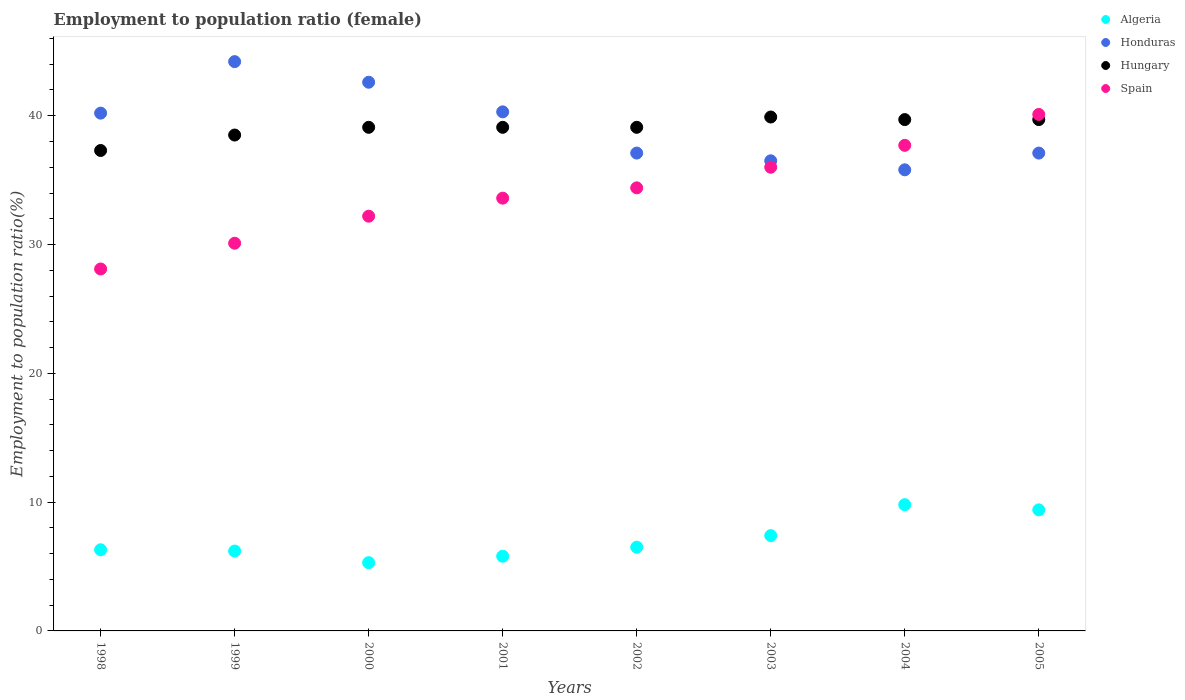How many different coloured dotlines are there?
Make the answer very short. 4. What is the employment to population ratio in Honduras in 2000?
Your response must be concise. 42.6. Across all years, what is the maximum employment to population ratio in Spain?
Offer a terse response. 40.1. Across all years, what is the minimum employment to population ratio in Spain?
Make the answer very short. 28.1. In which year was the employment to population ratio in Algeria minimum?
Your answer should be compact. 2000. What is the total employment to population ratio in Hungary in the graph?
Ensure brevity in your answer.  312.4. What is the difference between the employment to population ratio in Algeria in 2000 and that in 2002?
Your answer should be compact. -1.2. What is the difference between the employment to population ratio in Spain in 1998 and the employment to population ratio in Honduras in 1999?
Give a very brief answer. -16.1. What is the average employment to population ratio in Hungary per year?
Give a very brief answer. 39.05. In the year 2003, what is the difference between the employment to population ratio in Hungary and employment to population ratio in Spain?
Your response must be concise. 3.9. In how many years, is the employment to population ratio in Honduras greater than 14 %?
Keep it short and to the point. 8. What is the ratio of the employment to population ratio in Algeria in 1998 to that in 2003?
Make the answer very short. 0.85. Is the employment to population ratio in Spain in 2001 less than that in 2004?
Your answer should be very brief. Yes. Is the difference between the employment to population ratio in Hungary in 2000 and 2005 greater than the difference between the employment to population ratio in Spain in 2000 and 2005?
Provide a short and direct response. Yes. What is the difference between the highest and the second highest employment to population ratio in Spain?
Keep it short and to the point. 2.4. What is the difference between the highest and the lowest employment to population ratio in Spain?
Your answer should be compact. 12. In how many years, is the employment to population ratio in Algeria greater than the average employment to population ratio in Algeria taken over all years?
Make the answer very short. 3. Is it the case that in every year, the sum of the employment to population ratio in Hungary and employment to population ratio in Spain  is greater than the sum of employment to population ratio in Algeria and employment to population ratio in Honduras?
Keep it short and to the point. No. Is it the case that in every year, the sum of the employment to population ratio in Spain and employment to population ratio in Honduras  is greater than the employment to population ratio in Algeria?
Your answer should be compact. Yes. Is the employment to population ratio in Honduras strictly greater than the employment to population ratio in Algeria over the years?
Your answer should be compact. Yes. Is the employment to population ratio in Honduras strictly less than the employment to population ratio in Hungary over the years?
Your response must be concise. No. Are the values on the major ticks of Y-axis written in scientific E-notation?
Ensure brevity in your answer.  No. Does the graph contain grids?
Your response must be concise. No. Where does the legend appear in the graph?
Keep it short and to the point. Top right. How many legend labels are there?
Offer a terse response. 4. How are the legend labels stacked?
Ensure brevity in your answer.  Vertical. What is the title of the graph?
Provide a succinct answer. Employment to population ratio (female). Does "Austria" appear as one of the legend labels in the graph?
Offer a terse response. No. What is the Employment to population ratio(%) of Algeria in 1998?
Offer a very short reply. 6.3. What is the Employment to population ratio(%) of Honduras in 1998?
Provide a succinct answer. 40.2. What is the Employment to population ratio(%) of Hungary in 1998?
Your answer should be compact. 37.3. What is the Employment to population ratio(%) in Spain in 1998?
Give a very brief answer. 28.1. What is the Employment to population ratio(%) of Algeria in 1999?
Provide a succinct answer. 6.2. What is the Employment to population ratio(%) of Honduras in 1999?
Offer a terse response. 44.2. What is the Employment to population ratio(%) in Hungary in 1999?
Your answer should be very brief. 38.5. What is the Employment to population ratio(%) in Spain in 1999?
Provide a short and direct response. 30.1. What is the Employment to population ratio(%) of Algeria in 2000?
Give a very brief answer. 5.3. What is the Employment to population ratio(%) of Honduras in 2000?
Offer a terse response. 42.6. What is the Employment to population ratio(%) of Hungary in 2000?
Your response must be concise. 39.1. What is the Employment to population ratio(%) in Spain in 2000?
Your answer should be compact. 32.2. What is the Employment to population ratio(%) of Algeria in 2001?
Ensure brevity in your answer.  5.8. What is the Employment to population ratio(%) in Honduras in 2001?
Give a very brief answer. 40.3. What is the Employment to population ratio(%) of Hungary in 2001?
Offer a very short reply. 39.1. What is the Employment to population ratio(%) in Spain in 2001?
Your answer should be very brief. 33.6. What is the Employment to population ratio(%) in Honduras in 2002?
Offer a very short reply. 37.1. What is the Employment to population ratio(%) in Hungary in 2002?
Your answer should be compact. 39.1. What is the Employment to population ratio(%) in Spain in 2002?
Ensure brevity in your answer.  34.4. What is the Employment to population ratio(%) of Algeria in 2003?
Your response must be concise. 7.4. What is the Employment to population ratio(%) in Honduras in 2003?
Provide a succinct answer. 36.5. What is the Employment to population ratio(%) in Hungary in 2003?
Make the answer very short. 39.9. What is the Employment to population ratio(%) of Spain in 2003?
Offer a terse response. 36. What is the Employment to population ratio(%) of Algeria in 2004?
Your answer should be compact. 9.8. What is the Employment to population ratio(%) of Honduras in 2004?
Ensure brevity in your answer.  35.8. What is the Employment to population ratio(%) of Hungary in 2004?
Provide a succinct answer. 39.7. What is the Employment to population ratio(%) in Spain in 2004?
Make the answer very short. 37.7. What is the Employment to population ratio(%) of Algeria in 2005?
Offer a very short reply. 9.4. What is the Employment to population ratio(%) in Honduras in 2005?
Offer a terse response. 37.1. What is the Employment to population ratio(%) of Hungary in 2005?
Your answer should be compact. 39.7. What is the Employment to population ratio(%) in Spain in 2005?
Ensure brevity in your answer.  40.1. Across all years, what is the maximum Employment to population ratio(%) in Algeria?
Your answer should be compact. 9.8. Across all years, what is the maximum Employment to population ratio(%) of Honduras?
Provide a succinct answer. 44.2. Across all years, what is the maximum Employment to population ratio(%) of Hungary?
Provide a short and direct response. 39.9. Across all years, what is the maximum Employment to population ratio(%) of Spain?
Offer a terse response. 40.1. Across all years, what is the minimum Employment to population ratio(%) of Algeria?
Offer a terse response. 5.3. Across all years, what is the minimum Employment to population ratio(%) of Honduras?
Your response must be concise. 35.8. Across all years, what is the minimum Employment to population ratio(%) of Hungary?
Provide a succinct answer. 37.3. Across all years, what is the minimum Employment to population ratio(%) in Spain?
Ensure brevity in your answer.  28.1. What is the total Employment to population ratio(%) of Algeria in the graph?
Keep it short and to the point. 56.7. What is the total Employment to population ratio(%) of Honduras in the graph?
Give a very brief answer. 313.8. What is the total Employment to population ratio(%) of Hungary in the graph?
Provide a succinct answer. 312.4. What is the total Employment to population ratio(%) of Spain in the graph?
Provide a short and direct response. 272.2. What is the difference between the Employment to population ratio(%) of Algeria in 1998 and that in 1999?
Your answer should be compact. 0.1. What is the difference between the Employment to population ratio(%) in Hungary in 1998 and that in 1999?
Keep it short and to the point. -1.2. What is the difference between the Employment to population ratio(%) of Spain in 1998 and that in 1999?
Your answer should be very brief. -2. What is the difference between the Employment to population ratio(%) in Honduras in 1998 and that in 2000?
Give a very brief answer. -2.4. What is the difference between the Employment to population ratio(%) in Hungary in 1998 and that in 2000?
Offer a very short reply. -1.8. What is the difference between the Employment to population ratio(%) in Honduras in 1998 and that in 2001?
Your answer should be compact. -0.1. What is the difference between the Employment to population ratio(%) in Algeria in 1998 and that in 2002?
Make the answer very short. -0.2. What is the difference between the Employment to population ratio(%) of Honduras in 1998 and that in 2002?
Ensure brevity in your answer.  3.1. What is the difference between the Employment to population ratio(%) in Hungary in 1998 and that in 2002?
Your answer should be compact. -1.8. What is the difference between the Employment to population ratio(%) of Spain in 1998 and that in 2002?
Ensure brevity in your answer.  -6.3. What is the difference between the Employment to population ratio(%) in Algeria in 1998 and that in 2003?
Offer a very short reply. -1.1. What is the difference between the Employment to population ratio(%) of Hungary in 1998 and that in 2003?
Your response must be concise. -2.6. What is the difference between the Employment to population ratio(%) in Algeria in 1998 and that in 2004?
Your response must be concise. -3.5. What is the difference between the Employment to population ratio(%) in Honduras in 1998 and that in 2004?
Your answer should be compact. 4.4. What is the difference between the Employment to population ratio(%) of Spain in 1998 and that in 2004?
Your response must be concise. -9.6. What is the difference between the Employment to population ratio(%) in Hungary in 1998 and that in 2005?
Your answer should be very brief. -2.4. What is the difference between the Employment to population ratio(%) of Algeria in 1999 and that in 2000?
Make the answer very short. 0.9. What is the difference between the Employment to population ratio(%) in Hungary in 1999 and that in 2000?
Give a very brief answer. -0.6. What is the difference between the Employment to population ratio(%) of Spain in 1999 and that in 2001?
Provide a succinct answer. -3.5. What is the difference between the Employment to population ratio(%) in Algeria in 1999 and that in 2002?
Make the answer very short. -0.3. What is the difference between the Employment to population ratio(%) in Honduras in 1999 and that in 2002?
Give a very brief answer. 7.1. What is the difference between the Employment to population ratio(%) of Spain in 1999 and that in 2002?
Make the answer very short. -4.3. What is the difference between the Employment to population ratio(%) of Honduras in 1999 and that in 2003?
Offer a terse response. 7.7. What is the difference between the Employment to population ratio(%) in Hungary in 1999 and that in 2003?
Your response must be concise. -1.4. What is the difference between the Employment to population ratio(%) in Algeria in 1999 and that in 2004?
Your answer should be compact. -3.6. What is the difference between the Employment to population ratio(%) of Spain in 1999 and that in 2004?
Give a very brief answer. -7.6. What is the difference between the Employment to population ratio(%) in Honduras in 1999 and that in 2005?
Ensure brevity in your answer.  7.1. What is the difference between the Employment to population ratio(%) of Spain in 1999 and that in 2005?
Give a very brief answer. -10. What is the difference between the Employment to population ratio(%) of Algeria in 2000 and that in 2001?
Provide a succinct answer. -0.5. What is the difference between the Employment to population ratio(%) in Hungary in 2000 and that in 2001?
Give a very brief answer. 0. What is the difference between the Employment to population ratio(%) in Spain in 2000 and that in 2001?
Ensure brevity in your answer.  -1.4. What is the difference between the Employment to population ratio(%) in Honduras in 2000 and that in 2002?
Your response must be concise. 5.5. What is the difference between the Employment to population ratio(%) in Algeria in 2000 and that in 2003?
Your response must be concise. -2.1. What is the difference between the Employment to population ratio(%) in Algeria in 2000 and that in 2004?
Offer a terse response. -4.5. What is the difference between the Employment to population ratio(%) of Honduras in 2000 and that in 2004?
Your response must be concise. 6.8. What is the difference between the Employment to population ratio(%) in Algeria in 2000 and that in 2005?
Give a very brief answer. -4.1. What is the difference between the Employment to population ratio(%) of Hungary in 2000 and that in 2005?
Provide a short and direct response. -0.6. What is the difference between the Employment to population ratio(%) in Algeria in 2001 and that in 2002?
Your answer should be compact. -0.7. What is the difference between the Employment to population ratio(%) in Honduras in 2001 and that in 2002?
Your response must be concise. 3.2. What is the difference between the Employment to population ratio(%) of Spain in 2001 and that in 2002?
Keep it short and to the point. -0.8. What is the difference between the Employment to population ratio(%) in Honduras in 2001 and that in 2003?
Make the answer very short. 3.8. What is the difference between the Employment to population ratio(%) in Spain in 2001 and that in 2003?
Make the answer very short. -2.4. What is the difference between the Employment to population ratio(%) of Hungary in 2001 and that in 2004?
Provide a succinct answer. -0.6. What is the difference between the Employment to population ratio(%) of Spain in 2001 and that in 2004?
Keep it short and to the point. -4.1. What is the difference between the Employment to population ratio(%) of Algeria in 2001 and that in 2005?
Your response must be concise. -3.6. What is the difference between the Employment to population ratio(%) of Hungary in 2001 and that in 2005?
Your response must be concise. -0.6. What is the difference between the Employment to population ratio(%) of Spain in 2001 and that in 2005?
Make the answer very short. -6.5. What is the difference between the Employment to population ratio(%) of Honduras in 2002 and that in 2003?
Your answer should be compact. 0.6. What is the difference between the Employment to population ratio(%) in Hungary in 2002 and that in 2003?
Provide a short and direct response. -0.8. What is the difference between the Employment to population ratio(%) of Spain in 2002 and that in 2003?
Provide a short and direct response. -1.6. What is the difference between the Employment to population ratio(%) in Hungary in 2002 and that in 2004?
Ensure brevity in your answer.  -0.6. What is the difference between the Employment to population ratio(%) in Spain in 2002 and that in 2004?
Your answer should be compact. -3.3. What is the difference between the Employment to population ratio(%) of Honduras in 2003 and that in 2004?
Provide a short and direct response. 0.7. What is the difference between the Employment to population ratio(%) in Hungary in 2003 and that in 2004?
Keep it short and to the point. 0.2. What is the difference between the Employment to population ratio(%) of Algeria in 2003 and that in 2005?
Offer a terse response. -2. What is the difference between the Employment to population ratio(%) of Hungary in 2003 and that in 2005?
Make the answer very short. 0.2. What is the difference between the Employment to population ratio(%) of Algeria in 2004 and that in 2005?
Offer a terse response. 0.4. What is the difference between the Employment to population ratio(%) of Hungary in 2004 and that in 2005?
Your answer should be compact. 0. What is the difference between the Employment to population ratio(%) of Spain in 2004 and that in 2005?
Your response must be concise. -2.4. What is the difference between the Employment to population ratio(%) of Algeria in 1998 and the Employment to population ratio(%) of Honduras in 1999?
Offer a very short reply. -37.9. What is the difference between the Employment to population ratio(%) in Algeria in 1998 and the Employment to population ratio(%) in Hungary in 1999?
Keep it short and to the point. -32.2. What is the difference between the Employment to population ratio(%) of Algeria in 1998 and the Employment to population ratio(%) of Spain in 1999?
Offer a terse response. -23.8. What is the difference between the Employment to population ratio(%) of Algeria in 1998 and the Employment to population ratio(%) of Honduras in 2000?
Make the answer very short. -36.3. What is the difference between the Employment to population ratio(%) in Algeria in 1998 and the Employment to population ratio(%) in Hungary in 2000?
Provide a short and direct response. -32.8. What is the difference between the Employment to population ratio(%) in Algeria in 1998 and the Employment to population ratio(%) in Spain in 2000?
Offer a very short reply. -25.9. What is the difference between the Employment to population ratio(%) of Honduras in 1998 and the Employment to population ratio(%) of Spain in 2000?
Offer a terse response. 8. What is the difference between the Employment to population ratio(%) of Algeria in 1998 and the Employment to population ratio(%) of Honduras in 2001?
Offer a very short reply. -34. What is the difference between the Employment to population ratio(%) in Algeria in 1998 and the Employment to population ratio(%) in Hungary in 2001?
Ensure brevity in your answer.  -32.8. What is the difference between the Employment to population ratio(%) in Algeria in 1998 and the Employment to population ratio(%) in Spain in 2001?
Keep it short and to the point. -27.3. What is the difference between the Employment to population ratio(%) in Honduras in 1998 and the Employment to population ratio(%) in Hungary in 2001?
Offer a terse response. 1.1. What is the difference between the Employment to population ratio(%) of Honduras in 1998 and the Employment to population ratio(%) of Spain in 2001?
Provide a succinct answer. 6.6. What is the difference between the Employment to population ratio(%) in Hungary in 1998 and the Employment to population ratio(%) in Spain in 2001?
Ensure brevity in your answer.  3.7. What is the difference between the Employment to population ratio(%) of Algeria in 1998 and the Employment to population ratio(%) of Honduras in 2002?
Offer a very short reply. -30.8. What is the difference between the Employment to population ratio(%) in Algeria in 1998 and the Employment to population ratio(%) in Hungary in 2002?
Offer a very short reply. -32.8. What is the difference between the Employment to population ratio(%) of Algeria in 1998 and the Employment to population ratio(%) of Spain in 2002?
Make the answer very short. -28.1. What is the difference between the Employment to population ratio(%) of Hungary in 1998 and the Employment to population ratio(%) of Spain in 2002?
Provide a succinct answer. 2.9. What is the difference between the Employment to population ratio(%) in Algeria in 1998 and the Employment to population ratio(%) in Honduras in 2003?
Your response must be concise. -30.2. What is the difference between the Employment to population ratio(%) of Algeria in 1998 and the Employment to population ratio(%) of Hungary in 2003?
Keep it short and to the point. -33.6. What is the difference between the Employment to population ratio(%) in Algeria in 1998 and the Employment to population ratio(%) in Spain in 2003?
Make the answer very short. -29.7. What is the difference between the Employment to population ratio(%) in Honduras in 1998 and the Employment to population ratio(%) in Spain in 2003?
Offer a terse response. 4.2. What is the difference between the Employment to population ratio(%) in Algeria in 1998 and the Employment to population ratio(%) in Honduras in 2004?
Offer a terse response. -29.5. What is the difference between the Employment to population ratio(%) of Algeria in 1998 and the Employment to population ratio(%) of Hungary in 2004?
Provide a succinct answer. -33.4. What is the difference between the Employment to population ratio(%) of Algeria in 1998 and the Employment to population ratio(%) of Spain in 2004?
Ensure brevity in your answer.  -31.4. What is the difference between the Employment to population ratio(%) in Honduras in 1998 and the Employment to population ratio(%) in Hungary in 2004?
Keep it short and to the point. 0.5. What is the difference between the Employment to population ratio(%) of Algeria in 1998 and the Employment to population ratio(%) of Honduras in 2005?
Provide a succinct answer. -30.8. What is the difference between the Employment to population ratio(%) in Algeria in 1998 and the Employment to population ratio(%) in Hungary in 2005?
Your answer should be compact. -33.4. What is the difference between the Employment to population ratio(%) of Algeria in 1998 and the Employment to population ratio(%) of Spain in 2005?
Your response must be concise. -33.8. What is the difference between the Employment to population ratio(%) of Honduras in 1998 and the Employment to population ratio(%) of Hungary in 2005?
Your answer should be very brief. 0.5. What is the difference between the Employment to population ratio(%) of Hungary in 1998 and the Employment to population ratio(%) of Spain in 2005?
Offer a very short reply. -2.8. What is the difference between the Employment to population ratio(%) in Algeria in 1999 and the Employment to population ratio(%) in Honduras in 2000?
Your answer should be compact. -36.4. What is the difference between the Employment to population ratio(%) in Algeria in 1999 and the Employment to population ratio(%) in Hungary in 2000?
Provide a short and direct response. -32.9. What is the difference between the Employment to population ratio(%) in Honduras in 1999 and the Employment to population ratio(%) in Hungary in 2000?
Your response must be concise. 5.1. What is the difference between the Employment to population ratio(%) in Honduras in 1999 and the Employment to population ratio(%) in Spain in 2000?
Provide a short and direct response. 12. What is the difference between the Employment to population ratio(%) of Hungary in 1999 and the Employment to population ratio(%) of Spain in 2000?
Offer a terse response. 6.3. What is the difference between the Employment to population ratio(%) of Algeria in 1999 and the Employment to population ratio(%) of Honduras in 2001?
Provide a succinct answer. -34.1. What is the difference between the Employment to population ratio(%) in Algeria in 1999 and the Employment to population ratio(%) in Hungary in 2001?
Your response must be concise. -32.9. What is the difference between the Employment to population ratio(%) in Algeria in 1999 and the Employment to population ratio(%) in Spain in 2001?
Make the answer very short. -27.4. What is the difference between the Employment to population ratio(%) of Honduras in 1999 and the Employment to population ratio(%) of Hungary in 2001?
Provide a short and direct response. 5.1. What is the difference between the Employment to population ratio(%) of Hungary in 1999 and the Employment to population ratio(%) of Spain in 2001?
Provide a succinct answer. 4.9. What is the difference between the Employment to population ratio(%) in Algeria in 1999 and the Employment to population ratio(%) in Honduras in 2002?
Keep it short and to the point. -30.9. What is the difference between the Employment to population ratio(%) of Algeria in 1999 and the Employment to population ratio(%) of Hungary in 2002?
Give a very brief answer. -32.9. What is the difference between the Employment to population ratio(%) in Algeria in 1999 and the Employment to population ratio(%) in Spain in 2002?
Offer a very short reply. -28.2. What is the difference between the Employment to population ratio(%) in Algeria in 1999 and the Employment to population ratio(%) in Honduras in 2003?
Keep it short and to the point. -30.3. What is the difference between the Employment to population ratio(%) of Algeria in 1999 and the Employment to population ratio(%) of Hungary in 2003?
Ensure brevity in your answer.  -33.7. What is the difference between the Employment to population ratio(%) in Algeria in 1999 and the Employment to population ratio(%) in Spain in 2003?
Keep it short and to the point. -29.8. What is the difference between the Employment to population ratio(%) of Honduras in 1999 and the Employment to population ratio(%) of Hungary in 2003?
Give a very brief answer. 4.3. What is the difference between the Employment to population ratio(%) in Hungary in 1999 and the Employment to population ratio(%) in Spain in 2003?
Provide a short and direct response. 2.5. What is the difference between the Employment to population ratio(%) of Algeria in 1999 and the Employment to population ratio(%) of Honduras in 2004?
Ensure brevity in your answer.  -29.6. What is the difference between the Employment to population ratio(%) in Algeria in 1999 and the Employment to population ratio(%) in Hungary in 2004?
Your response must be concise. -33.5. What is the difference between the Employment to population ratio(%) of Algeria in 1999 and the Employment to population ratio(%) of Spain in 2004?
Keep it short and to the point. -31.5. What is the difference between the Employment to population ratio(%) of Hungary in 1999 and the Employment to population ratio(%) of Spain in 2004?
Make the answer very short. 0.8. What is the difference between the Employment to population ratio(%) of Algeria in 1999 and the Employment to population ratio(%) of Honduras in 2005?
Your response must be concise. -30.9. What is the difference between the Employment to population ratio(%) of Algeria in 1999 and the Employment to population ratio(%) of Hungary in 2005?
Give a very brief answer. -33.5. What is the difference between the Employment to population ratio(%) in Algeria in 1999 and the Employment to population ratio(%) in Spain in 2005?
Your response must be concise. -33.9. What is the difference between the Employment to population ratio(%) in Honduras in 1999 and the Employment to population ratio(%) in Hungary in 2005?
Provide a short and direct response. 4.5. What is the difference between the Employment to population ratio(%) of Algeria in 2000 and the Employment to population ratio(%) of Honduras in 2001?
Offer a terse response. -35. What is the difference between the Employment to population ratio(%) in Algeria in 2000 and the Employment to population ratio(%) in Hungary in 2001?
Offer a terse response. -33.8. What is the difference between the Employment to population ratio(%) in Algeria in 2000 and the Employment to population ratio(%) in Spain in 2001?
Offer a very short reply. -28.3. What is the difference between the Employment to population ratio(%) of Honduras in 2000 and the Employment to population ratio(%) of Hungary in 2001?
Your response must be concise. 3.5. What is the difference between the Employment to population ratio(%) in Algeria in 2000 and the Employment to population ratio(%) in Honduras in 2002?
Offer a terse response. -31.8. What is the difference between the Employment to population ratio(%) in Algeria in 2000 and the Employment to population ratio(%) in Hungary in 2002?
Offer a very short reply. -33.8. What is the difference between the Employment to population ratio(%) in Algeria in 2000 and the Employment to population ratio(%) in Spain in 2002?
Keep it short and to the point. -29.1. What is the difference between the Employment to population ratio(%) of Honduras in 2000 and the Employment to population ratio(%) of Spain in 2002?
Give a very brief answer. 8.2. What is the difference between the Employment to population ratio(%) in Hungary in 2000 and the Employment to population ratio(%) in Spain in 2002?
Provide a short and direct response. 4.7. What is the difference between the Employment to population ratio(%) of Algeria in 2000 and the Employment to population ratio(%) of Honduras in 2003?
Keep it short and to the point. -31.2. What is the difference between the Employment to population ratio(%) in Algeria in 2000 and the Employment to population ratio(%) in Hungary in 2003?
Make the answer very short. -34.6. What is the difference between the Employment to population ratio(%) of Algeria in 2000 and the Employment to population ratio(%) of Spain in 2003?
Your answer should be very brief. -30.7. What is the difference between the Employment to population ratio(%) in Honduras in 2000 and the Employment to population ratio(%) in Hungary in 2003?
Make the answer very short. 2.7. What is the difference between the Employment to population ratio(%) of Hungary in 2000 and the Employment to population ratio(%) of Spain in 2003?
Keep it short and to the point. 3.1. What is the difference between the Employment to population ratio(%) in Algeria in 2000 and the Employment to population ratio(%) in Honduras in 2004?
Your response must be concise. -30.5. What is the difference between the Employment to population ratio(%) in Algeria in 2000 and the Employment to population ratio(%) in Hungary in 2004?
Keep it short and to the point. -34.4. What is the difference between the Employment to population ratio(%) of Algeria in 2000 and the Employment to population ratio(%) of Spain in 2004?
Make the answer very short. -32.4. What is the difference between the Employment to population ratio(%) in Honduras in 2000 and the Employment to population ratio(%) in Spain in 2004?
Your response must be concise. 4.9. What is the difference between the Employment to population ratio(%) of Algeria in 2000 and the Employment to population ratio(%) of Honduras in 2005?
Offer a terse response. -31.8. What is the difference between the Employment to population ratio(%) of Algeria in 2000 and the Employment to population ratio(%) of Hungary in 2005?
Ensure brevity in your answer.  -34.4. What is the difference between the Employment to population ratio(%) in Algeria in 2000 and the Employment to population ratio(%) in Spain in 2005?
Ensure brevity in your answer.  -34.8. What is the difference between the Employment to population ratio(%) in Honduras in 2000 and the Employment to population ratio(%) in Hungary in 2005?
Make the answer very short. 2.9. What is the difference between the Employment to population ratio(%) of Algeria in 2001 and the Employment to population ratio(%) of Honduras in 2002?
Your answer should be compact. -31.3. What is the difference between the Employment to population ratio(%) of Algeria in 2001 and the Employment to population ratio(%) of Hungary in 2002?
Ensure brevity in your answer.  -33.3. What is the difference between the Employment to population ratio(%) of Algeria in 2001 and the Employment to population ratio(%) of Spain in 2002?
Your answer should be compact. -28.6. What is the difference between the Employment to population ratio(%) of Honduras in 2001 and the Employment to population ratio(%) of Hungary in 2002?
Give a very brief answer. 1.2. What is the difference between the Employment to population ratio(%) of Hungary in 2001 and the Employment to population ratio(%) of Spain in 2002?
Make the answer very short. 4.7. What is the difference between the Employment to population ratio(%) of Algeria in 2001 and the Employment to population ratio(%) of Honduras in 2003?
Your answer should be very brief. -30.7. What is the difference between the Employment to population ratio(%) of Algeria in 2001 and the Employment to population ratio(%) of Hungary in 2003?
Keep it short and to the point. -34.1. What is the difference between the Employment to population ratio(%) in Algeria in 2001 and the Employment to population ratio(%) in Spain in 2003?
Offer a very short reply. -30.2. What is the difference between the Employment to population ratio(%) of Honduras in 2001 and the Employment to population ratio(%) of Spain in 2003?
Ensure brevity in your answer.  4.3. What is the difference between the Employment to population ratio(%) in Hungary in 2001 and the Employment to population ratio(%) in Spain in 2003?
Your answer should be very brief. 3.1. What is the difference between the Employment to population ratio(%) of Algeria in 2001 and the Employment to population ratio(%) of Honduras in 2004?
Offer a very short reply. -30. What is the difference between the Employment to population ratio(%) of Algeria in 2001 and the Employment to population ratio(%) of Hungary in 2004?
Provide a short and direct response. -33.9. What is the difference between the Employment to population ratio(%) in Algeria in 2001 and the Employment to population ratio(%) in Spain in 2004?
Ensure brevity in your answer.  -31.9. What is the difference between the Employment to population ratio(%) of Honduras in 2001 and the Employment to population ratio(%) of Hungary in 2004?
Keep it short and to the point. 0.6. What is the difference between the Employment to population ratio(%) in Algeria in 2001 and the Employment to population ratio(%) in Honduras in 2005?
Give a very brief answer. -31.3. What is the difference between the Employment to population ratio(%) in Algeria in 2001 and the Employment to population ratio(%) in Hungary in 2005?
Offer a very short reply. -33.9. What is the difference between the Employment to population ratio(%) in Algeria in 2001 and the Employment to population ratio(%) in Spain in 2005?
Offer a very short reply. -34.3. What is the difference between the Employment to population ratio(%) of Honduras in 2001 and the Employment to population ratio(%) of Hungary in 2005?
Offer a very short reply. 0.6. What is the difference between the Employment to population ratio(%) of Honduras in 2001 and the Employment to population ratio(%) of Spain in 2005?
Offer a terse response. 0.2. What is the difference between the Employment to population ratio(%) of Algeria in 2002 and the Employment to population ratio(%) of Hungary in 2003?
Give a very brief answer. -33.4. What is the difference between the Employment to population ratio(%) of Algeria in 2002 and the Employment to population ratio(%) of Spain in 2003?
Provide a succinct answer. -29.5. What is the difference between the Employment to population ratio(%) in Honduras in 2002 and the Employment to population ratio(%) in Hungary in 2003?
Provide a succinct answer. -2.8. What is the difference between the Employment to population ratio(%) in Honduras in 2002 and the Employment to population ratio(%) in Spain in 2003?
Your response must be concise. 1.1. What is the difference between the Employment to population ratio(%) in Hungary in 2002 and the Employment to population ratio(%) in Spain in 2003?
Keep it short and to the point. 3.1. What is the difference between the Employment to population ratio(%) of Algeria in 2002 and the Employment to population ratio(%) of Honduras in 2004?
Offer a very short reply. -29.3. What is the difference between the Employment to population ratio(%) of Algeria in 2002 and the Employment to population ratio(%) of Hungary in 2004?
Keep it short and to the point. -33.2. What is the difference between the Employment to population ratio(%) of Algeria in 2002 and the Employment to population ratio(%) of Spain in 2004?
Offer a very short reply. -31.2. What is the difference between the Employment to population ratio(%) of Honduras in 2002 and the Employment to population ratio(%) of Spain in 2004?
Provide a succinct answer. -0.6. What is the difference between the Employment to population ratio(%) of Hungary in 2002 and the Employment to population ratio(%) of Spain in 2004?
Provide a short and direct response. 1.4. What is the difference between the Employment to population ratio(%) in Algeria in 2002 and the Employment to population ratio(%) in Honduras in 2005?
Offer a very short reply. -30.6. What is the difference between the Employment to population ratio(%) of Algeria in 2002 and the Employment to population ratio(%) of Hungary in 2005?
Your response must be concise. -33.2. What is the difference between the Employment to population ratio(%) of Algeria in 2002 and the Employment to population ratio(%) of Spain in 2005?
Offer a terse response. -33.6. What is the difference between the Employment to population ratio(%) of Honduras in 2002 and the Employment to population ratio(%) of Hungary in 2005?
Provide a succinct answer. -2.6. What is the difference between the Employment to population ratio(%) in Hungary in 2002 and the Employment to population ratio(%) in Spain in 2005?
Provide a succinct answer. -1. What is the difference between the Employment to population ratio(%) of Algeria in 2003 and the Employment to population ratio(%) of Honduras in 2004?
Offer a very short reply. -28.4. What is the difference between the Employment to population ratio(%) of Algeria in 2003 and the Employment to population ratio(%) of Hungary in 2004?
Provide a short and direct response. -32.3. What is the difference between the Employment to population ratio(%) in Algeria in 2003 and the Employment to population ratio(%) in Spain in 2004?
Your answer should be very brief. -30.3. What is the difference between the Employment to population ratio(%) in Algeria in 2003 and the Employment to population ratio(%) in Honduras in 2005?
Your response must be concise. -29.7. What is the difference between the Employment to population ratio(%) in Algeria in 2003 and the Employment to population ratio(%) in Hungary in 2005?
Your answer should be very brief. -32.3. What is the difference between the Employment to population ratio(%) of Algeria in 2003 and the Employment to population ratio(%) of Spain in 2005?
Provide a short and direct response. -32.7. What is the difference between the Employment to population ratio(%) in Honduras in 2003 and the Employment to population ratio(%) in Hungary in 2005?
Provide a short and direct response. -3.2. What is the difference between the Employment to population ratio(%) in Hungary in 2003 and the Employment to population ratio(%) in Spain in 2005?
Provide a succinct answer. -0.2. What is the difference between the Employment to population ratio(%) in Algeria in 2004 and the Employment to population ratio(%) in Honduras in 2005?
Your answer should be very brief. -27.3. What is the difference between the Employment to population ratio(%) in Algeria in 2004 and the Employment to population ratio(%) in Hungary in 2005?
Offer a very short reply. -29.9. What is the difference between the Employment to population ratio(%) of Algeria in 2004 and the Employment to population ratio(%) of Spain in 2005?
Keep it short and to the point. -30.3. What is the average Employment to population ratio(%) in Algeria per year?
Ensure brevity in your answer.  7.09. What is the average Employment to population ratio(%) in Honduras per year?
Your answer should be very brief. 39.23. What is the average Employment to population ratio(%) in Hungary per year?
Your response must be concise. 39.05. What is the average Employment to population ratio(%) of Spain per year?
Provide a succinct answer. 34.02. In the year 1998, what is the difference between the Employment to population ratio(%) in Algeria and Employment to population ratio(%) in Honduras?
Your answer should be very brief. -33.9. In the year 1998, what is the difference between the Employment to population ratio(%) in Algeria and Employment to population ratio(%) in Hungary?
Offer a terse response. -31. In the year 1998, what is the difference between the Employment to population ratio(%) in Algeria and Employment to population ratio(%) in Spain?
Your response must be concise. -21.8. In the year 1998, what is the difference between the Employment to population ratio(%) in Honduras and Employment to population ratio(%) in Hungary?
Your answer should be very brief. 2.9. In the year 1998, what is the difference between the Employment to population ratio(%) in Honduras and Employment to population ratio(%) in Spain?
Make the answer very short. 12.1. In the year 1999, what is the difference between the Employment to population ratio(%) in Algeria and Employment to population ratio(%) in Honduras?
Provide a short and direct response. -38. In the year 1999, what is the difference between the Employment to population ratio(%) of Algeria and Employment to population ratio(%) of Hungary?
Make the answer very short. -32.3. In the year 1999, what is the difference between the Employment to population ratio(%) of Algeria and Employment to population ratio(%) of Spain?
Your answer should be compact. -23.9. In the year 1999, what is the difference between the Employment to population ratio(%) in Honduras and Employment to population ratio(%) in Hungary?
Keep it short and to the point. 5.7. In the year 1999, what is the difference between the Employment to population ratio(%) of Honduras and Employment to population ratio(%) of Spain?
Ensure brevity in your answer.  14.1. In the year 1999, what is the difference between the Employment to population ratio(%) in Hungary and Employment to population ratio(%) in Spain?
Provide a succinct answer. 8.4. In the year 2000, what is the difference between the Employment to population ratio(%) of Algeria and Employment to population ratio(%) of Honduras?
Make the answer very short. -37.3. In the year 2000, what is the difference between the Employment to population ratio(%) of Algeria and Employment to population ratio(%) of Hungary?
Make the answer very short. -33.8. In the year 2000, what is the difference between the Employment to population ratio(%) of Algeria and Employment to population ratio(%) of Spain?
Your answer should be compact. -26.9. In the year 2000, what is the difference between the Employment to population ratio(%) of Honduras and Employment to population ratio(%) of Hungary?
Your answer should be very brief. 3.5. In the year 2000, what is the difference between the Employment to population ratio(%) of Honduras and Employment to population ratio(%) of Spain?
Keep it short and to the point. 10.4. In the year 2000, what is the difference between the Employment to population ratio(%) in Hungary and Employment to population ratio(%) in Spain?
Ensure brevity in your answer.  6.9. In the year 2001, what is the difference between the Employment to population ratio(%) of Algeria and Employment to population ratio(%) of Honduras?
Your answer should be compact. -34.5. In the year 2001, what is the difference between the Employment to population ratio(%) of Algeria and Employment to population ratio(%) of Hungary?
Your answer should be compact. -33.3. In the year 2001, what is the difference between the Employment to population ratio(%) of Algeria and Employment to population ratio(%) of Spain?
Give a very brief answer. -27.8. In the year 2001, what is the difference between the Employment to population ratio(%) of Honduras and Employment to population ratio(%) of Hungary?
Your response must be concise. 1.2. In the year 2002, what is the difference between the Employment to population ratio(%) in Algeria and Employment to population ratio(%) in Honduras?
Offer a very short reply. -30.6. In the year 2002, what is the difference between the Employment to population ratio(%) of Algeria and Employment to population ratio(%) of Hungary?
Make the answer very short. -32.6. In the year 2002, what is the difference between the Employment to population ratio(%) in Algeria and Employment to population ratio(%) in Spain?
Offer a terse response. -27.9. In the year 2002, what is the difference between the Employment to population ratio(%) in Honduras and Employment to population ratio(%) in Hungary?
Your answer should be very brief. -2. In the year 2003, what is the difference between the Employment to population ratio(%) in Algeria and Employment to population ratio(%) in Honduras?
Provide a succinct answer. -29.1. In the year 2003, what is the difference between the Employment to population ratio(%) of Algeria and Employment to population ratio(%) of Hungary?
Your response must be concise. -32.5. In the year 2003, what is the difference between the Employment to population ratio(%) of Algeria and Employment to population ratio(%) of Spain?
Offer a very short reply. -28.6. In the year 2003, what is the difference between the Employment to population ratio(%) in Honduras and Employment to population ratio(%) in Spain?
Provide a succinct answer. 0.5. In the year 2003, what is the difference between the Employment to population ratio(%) in Hungary and Employment to population ratio(%) in Spain?
Give a very brief answer. 3.9. In the year 2004, what is the difference between the Employment to population ratio(%) of Algeria and Employment to population ratio(%) of Hungary?
Provide a succinct answer. -29.9. In the year 2004, what is the difference between the Employment to population ratio(%) of Algeria and Employment to population ratio(%) of Spain?
Keep it short and to the point. -27.9. In the year 2004, what is the difference between the Employment to population ratio(%) of Honduras and Employment to population ratio(%) of Hungary?
Offer a terse response. -3.9. In the year 2004, what is the difference between the Employment to population ratio(%) in Hungary and Employment to population ratio(%) in Spain?
Provide a short and direct response. 2. In the year 2005, what is the difference between the Employment to population ratio(%) in Algeria and Employment to population ratio(%) in Honduras?
Provide a short and direct response. -27.7. In the year 2005, what is the difference between the Employment to population ratio(%) of Algeria and Employment to population ratio(%) of Hungary?
Give a very brief answer. -30.3. In the year 2005, what is the difference between the Employment to population ratio(%) of Algeria and Employment to population ratio(%) of Spain?
Your answer should be compact. -30.7. In the year 2005, what is the difference between the Employment to population ratio(%) of Honduras and Employment to population ratio(%) of Hungary?
Your response must be concise. -2.6. In the year 2005, what is the difference between the Employment to population ratio(%) of Hungary and Employment to population ratio(%) of Spain?
Keep it short and to the point. -0.4. What is the ratio of the Employment to population ratio(%) in Algeria in 1998 to that in 1999?
Give a very brief answer. 1.02. What is the ratio of the Employment to population ratio(%) of Honduras in 1998 to that in 1999?
Offer a terse response. 0.91. What is the ratio of the Employment to population ratio(%) in Hungary in 1998 to that in 1999?
Your answer should be compact. 0.97. What is the ratio of the Employment to population ratio(%) in Spain in 1998 to that in 1999?
Provide a short and direct response. 0.93. What is the ratio of the Employment to population ratio(%) of Algeria in 1998 to that in 2000?
Your response must be concise. 1.19. What is the ratio of the Employment to population ratio(%) of Honduras in 1998 to that in 2000?
Ensure brevity in your answer.  0.94. What is the ratio of the Employment to population ratio(%) in Hungary in 1998 to that in 2000?
Keep it short and to the point. 0.95. What is the ratio of the Employment to population ratio(%) in Spain in 1998 to that in 2000?
Provide a succinct answer. 0.87. What is the ratio of the Employment to population ratio(%) of Algeria in 1998 to that in 2001?
Make the answer very short. 1.09. What is the ratio of the Employment to population ratio(%) of Honduras in 1998 to that in 2001?
Offer a very short reply. 1. What is the ratio of the Employment to population ratio(%) of Hungary in 1998 to that in 2001?
Keep it short and to the point. 0.95. What is the ratio of the Employment to population ratio(%) in Spain in 1998 to that in 2001?
Make the answer very short. 0.84. What is the ratio of the Employment to population ratio(%) of Algeria in 1998 to that in 2002?
Provide a succinct answer. 0.97. What is the ratio of the Employment to population ratio(%) of Honduras in 1998 to that in 2002?
Offer a very short reply. 1.08. What is the ratio of the Employment to population ratio(%) of Hungary in 1998 to that in 2002?
Provide a succinct answer. 0.95. What is the ratio of the Employment to population ratio(%) in Spain in 1998 to that in 2002?
Provide a short and direct response. 0.82. What is the ratio of the Employment to population ratio(%) of Algeria in 1998 to that in 2003?
Your response must be concise. 0.85. What is the ratio of the Employment to population ratio(%) in Honduras in 1998 to that in 2003?
Offer a very short reply. 1.1. What is the ratio of the Employment to population ratio(%) in Hungary in 1998 to that in 2003?
Offer a very short reply. 0.93. What is the ratio of the Employment to population ratio(%) in Spain in 1998 to that in 2003?
Your answer should be compact. 0.78. What is the ratio of the Employment to population ratio(%) in Algeria in 1998 to that in 2004?
Provide a succinct answer. 0.64. What is the ratio of the Employment to population ratio(%) of Honduras in 1998 to that in 2004?
Offer a terse response. 1.12. What is the ratio of the Employment to population ratio(%) of Hungary in 1998 to that in 2004?
Give a very brief answer. 0.94. What is the ratio of the Employment to population ratio(%) in Spain in 1998 to that in 2004?
Offer a terse response. 0.75. What is the ratio of the Employment to population ratio(%) in Algeria in 1998 to that in 2005?
Your answer should be very brief. 0.67. What is the ratio of the Employment to population ratio(%) of Honduras in 1998 to that in 2005?
Offer a terse response. 1.08. What is the ratio of the Employment to population ratio(%) of Hungary in 1998 to that in 2005?
Your answer should be compact. 0.94. What is the ratio of the Employment to population ratio(%) in Spain in 1998 to that in 2005?
Provide a short and direct response. 0.7. What is the ratio of the Employment to population ratio(%) in Algeria in 1999 to that in 2000?
Keep it short and to the point. 1.17. What is the ratio of the Employment to population ratio(%) of Honduras in 1999 to that in 2000?
Your answer should be very brief. 1.04. What is the ratio of the Employment to population ratio(%) in Hungary in 1999 to that in 2000?
Provide a succinct answer. 0.98. What is the ratio of the Employment to population ratio(%) of Spain in 1999 to that in 2000?
Your answer should be compact. 0.93. What is the ratio of the Employment to population ratio(%) of Algeria in 1999 to that in 2001?
Your answer should be very brief. 1.07. What is the ratio of the Employment to population ratio(%) in Honduras in 1999 to that in 2001?
Your answer should be very brief. 1.1. What is the ratio of the Employment to population ratio(%) in Hungary in 1999 to that in 2001?
Make the answer very short. 0.98. What is the ratio of the Employment to population ratio(%) of Spain in 1999 to that in 2001?
Offer a terse response. 0.9. What is the ratio of the Employment to population ratio(%) in Algeria in 1999 to that in 2002?
Offer a very short reply. 0.95. What is the ratio of the Employment to population ratio(%) of Honduras in 1999 to that in 2002?
Provide a succinct answer. 1.19. What is the ratio of the Employment to population ratio(%) of Hungary in 1999 to that in 2002?
Give a very brief answer. 0.98. What is the ratio of the Employment to population ratio(%) in Spain in 1999 to that in 2002?
Ensure brevity in your answer.  0.88. What is the ratio of the Employment to population ratio(%) in Algeria in 1999 to that in 2003?
Keep it short and to the point. 0.84. What is the ratio of the Employment to population ratio(%) of Honduras in 1999 to that in 2003?
Make the answer very short. 1.21. What is the ratio of the Employment to population ratio(%) of Hungary in 1999 to that in 2003?
Provide a short and direct response. 0.96. What is the ratio of the Employment to population ratio(%) in Spain in 1999 to that in 2003?
Offer a terse response. 0.84. What is the ratio of the Employment to population ratio(%) of Algeria in 1999 to that in 2004?
Your answer should be compact. 0.63. What is the ratio of the Employment to population ratio(%) of Honduras in 1999 to that in 2004?
Offer a terse response. 1.23. What is the ratio of the Employment to population ratio(%) of Hungary in 1999 to that in 2004?
Offer a terse response. 0.97. What is the ratio of the Employment to population ratio(%) in Spain in 1999 to that in 2004?
Offer a terse response. 0.8. What is the ratio of the Employment to population ratio(%) of Algeria in 1999 to that in 2005?
Keep it short and to the point. 0.66. What is the ratio of the Employment to population ratio(%) of Honduras in 1999 to that in 2005?
Your answer should be compact. 1.19. What is the ratio of the Employment to population ratio(%) of Hungary in 1999 to that in 2005?
Keep it short and to the point. 0.97. What is the ratio of the Employment to population ratio(%) of Spain in 1999 to that in 2005?
Give a very brief answer. 0.75. What is the ratio of the Employment to population ratio(%) of Algeria in 2000 to that in 2001?
Your response must be concise. 0.91. What is the ratio of the Employment to population ratio(%) in Honduras in 2000 to that in 2001?
Make the answer very short. 1.06. What is the ratio of the Employment to population ratio(%) of Algeria in 2000 to that in 2002?
Offer a terse response. 0.82. What is the ratio of the Employment to population ratio(%) of Honduras in 2000 to that in 2002?
Your answer should be compact. 1.15. What is the ratio of the Employment to population ratio(%) of Spain in 2000 to that in 2002?
Provide a short and direct response. 0.94. What is the ratio of the Employment to population ratio(%) in Algeria in 2000 to that in 2003?
Keep it short and to the point. 0.72. What is the ratio of the Employment to population ratio(%) in Honduras in 2000 to that in 2003?
Your answer should be very brief. 1.17. What is the ratio of the Employment to population ratio(%) of Hungary in 2000 to that in 2003?
Offer a very short reply. 0.98. What is the ratio of the Employment to population ratio(%) in Spain in 2000 to that in 2003?
Your response must be concise. 0.89. What is the ratio of the Employment to population ratio(%) of Algeria in 2000 to that in 2004?
Give a very brief answer. 0.54. What is the ratio of the Employment to population ratio(%) of Honduras in 2000 to that in 2004?
Offer a very short reply. 1.19. What is the ratio of the Employment to population ratio(%) in Hungary in 2000 to that in 2004?
Your answer should be very brief. 0.98. What is the ratio of the Employment to population ratio(%) in Spain in 2000 to that in 2004?
Provide a short and direct response. 0.85. What is the ratio of the Employment to population ratio(%) in Algeria in 2000 to that in 2005?
Your answer should be very brief. 0.56. What is the ratio of the Employment to population ratio(%) in Honduras in 2000 to that in 2005?
Offer a terse response. 1.15. What is the ratio of the Employment to population ratio(%) of Hungary in 2000 to that in 2005?
Give a very brief answer. 0.98. What is the ratio of the Employment to population ratio(%) of Spain in 2000 to that in 2005?
Provide a short and direct response. 0.8. What is the ratio of the Employment to population ratio(%) of Algeria in 2001 to that in 2002?
Offer a terse response. 0.89. What is the ratio of the Employment to population ratio(%) of Honduras in 2001 to that in 2002?
Provide a succinct answer. 1.09. What is the ratio of the Employment to population ratio(%) of Hungary in 2001 to that in 2002?
Ensure brevity in your answer.  1. What is the ratio of the Employment to population ratio(%) of Spain in 2001 to that in 2002?
Provide a short and direct response. 0.98. What is the ratio of the Employment to population ratio(%) of Algeria in 2001 to that in 2003?
Your answer should be very brief. 0.78. What is the ratio of the Employment to population ratio(%) in Honduras in 2001 to that in 2003?
Keep it short and to the point. 1.1. What is the ratio of the Employment to population ratio(%) in Hungary in 2001 to that in 2003?
Provide a short and direct response. 0.98. What is the ratio of the Employment to population ratio(%) of Spain in 2001 to that in 2003?
Ensure brevity in your answer.  0.93. What is the ratio of the Employment to population ratio(%) of Algeria in 2001 to that in 2004?
Your response must be concise. 0.59. What is the ratio of the Employment to population ratio(%) in Honduras in 2001 to that in 2004?
Provide a succinct answer. 1.13. What is the ratio of the Employment to population ratio(%) of Hungary in 2001 to that in 2004?
Ensure brevity in your answer.  0.98. What is the ratio of the Employment to population ratio(%) in Spain in 2001 to that in 2004?
Your response must be concise. 0.89. What is the ratio of the Employment to population ratio(%) in Algeria in 2001 to that in 2005?
Provide a short and direct response. 0.62. What is the ratio of the Employment to population ratio(%) in Honduras in 2001 to that in 2005?
Your answer should be very brief. 1.09. What is the ratio of the Employment to population ratio(%) of Hungary in 2001 to that in 2005?
Ensure brevity in your answer.  0.98. What is the ratio of the Employment to population ratio(%) of Spain in 2001 to that in 2005?
Ensure brevity in your answer.  0.84. What is the ratio of the Employment to population ratio(%) of Algeria in 2002 to that in 2003?
Ensure brevity in your answer.  0.88. What is the ratio of the Employment to population ratio(%) in Honduras in 2002 to that in 2003?
Offer a very short reply. 1.02. What is the ratio of the Employment to population ratio(%) in Hungary in 2002 to that in 2003?
Keep it short and to the point. 0.98. What is the ratio of the Employment to population ratio(%) in Spain in 2002 to that in 2003?
Ensure brevity in your answer.  0.96. What is the ratio of the Employment to population ratio(%) in Algeria in 2002 to that in 2004?
Provide a succinct answer. 0.66. What is the ratio of the Employment to population ratio(%) of Honduras in 2002 to that in 2004?
Your answer should be compact. 1.04. What is the ratio of the Employment to population ratio(%) of Hungary in 2002 to that in 2004?
Keep it short and to the point. 0.98. What is the ratio of the Employment to population ratio(%) of Spain in 2002 to that in 2004?
Your response must be concise. 0.91. What is the ratio of the Employment to population ratio(%) in Algeria in 2002 to that in 2005?
Provide a succinct answer. 0.69. What is the ratio of the Employment to population ratio(%) in Hungary in 2002 to that in 2005?
Keep it short and to the point. 0.98. What is the ratio of the Employment to population ratio(%) of Spain in 2002 to that in 2005?
Ensure brevity in your answer.  0.86. What is the ratio of the Employment to population ratio(%) of Algeria in 2003 to that in 2004?
Provide a short and direct response. 0.76. What is the ratio of the Employment to population ratio(%) in Honduras in 2003 to that in 2004?
Give a very brief answer. 1.02. What is the ratio of the Employment to population ratio(%) of Spain in 2003 to that in 2004?
Give a very brief answer. 0.95. What is the ratio of the Employment to population ratio(%) of Algeria in 2003 to that in 2005?
Give a very brief answer. 0.79. What is the ratio of the Employment to population ratio(%) of Honduras in 2003 to that in 2005?
Offer a terse response. 0.98. What is the ratio of the Employment to population ratio(%) in Spain in 2003 to that in 2005?
Provide a short and direct response. 0.9. What is the ratio of the Employment to population ratio(%) of Algeria in 2004 to that in 2005?
Give a very brief answer. 1.04. What is the ratio of the Employment to population ratio(%) of Honduras in 2004 to that in 2005?
Offer a very short reply. 0.96. What is the ratio of the Employment to population ratio(%) in Hungary in 2004 to that in 2005?
Your answer should be compact. 1. What is the ratio of the Employment to population ratio(%) in Spain in 2004 to that in 2005?
Provide a succinct answer. 0.94. What is the difference between the highest and the second highest Employment to population ratio(%) in Algeria?
Offer a terse response. 0.4. What is the difference between the highest and the second highest Employment to population ratio(%) of Honduras?
Give a very brief answer. 1.6. What is the difference between the highest and the second highest Employment to population ratio(%) in Hungary?
Make the answer very short. 0.2. What is the difference between the highest and the lowest Employment to population ratio(%) of Algeria?
Offer a terse response. 4.5. What is the difference between the highest and the lowest Employment to population ratio(%) in Spain?
Your response must be concise. 12. 